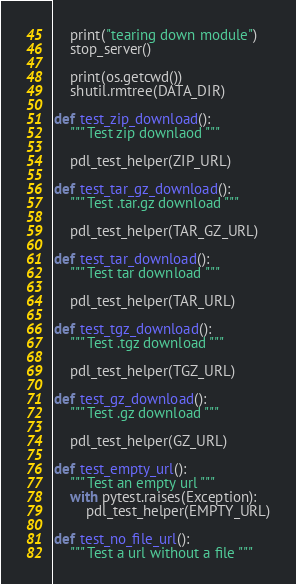<code> <loc_0><loc_0><loc_500><loc_500><_Python_>    print("tearing down module")
    stop_server()

    print(os.getcwd())
    shutil.rmtree(DATA_DIR)

def test_zip_download():
    """ Test zip downlaod """

    pdl_test_helper(ZIP_URL)

def test_tar_gz_download():
    """ Test .tar.gz download """

    pdl_test_helper(TAR_GZ_URL)

def test_tar_download():
    """ Test tar download """

    pdl_test_helper(TAR_URL)

def test_tgz_download():
    """ Test .tgz download """

    pdl_test_helper(TGZ_URL)

def test_gz_download():
    """ Test .gz download """

    pdl_test_helper(GZ_URL)

def test_empty_url():
    """ Test an empty url """
    with pytest.raises(Exception):
        pdl_test_helper(EMPTY_URL)

def test_no_file_url():
    """ Test a url without a file """</code> 